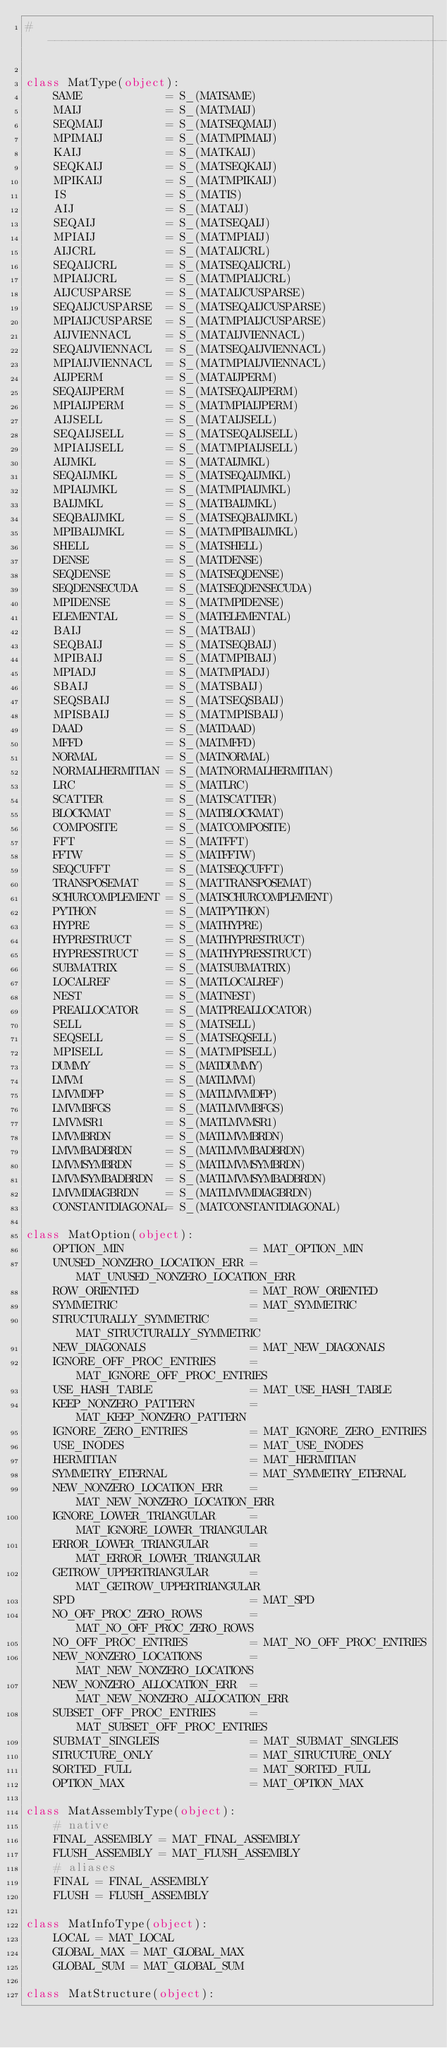Convert code to text. <code><loc_0><loc_0><loc_500><loc_500><_Cython_># --------------------------------------------------------------------

class MatType(object):
    SAME            = S_(MATSAME)
    MAIJ            = S_(MATMAIJ)
    SEQMAIJ         = S_(MATSEQMAIJ)
    MPIMAIJ         = S_(MATMPIMAIJ)
    KAIJ            = S_(MATKAIJ)
    SEQKAIJ         = S_(MATSEQKAIJ)
    MPIKAIJ         = S_(MATMPIKAIJ)
    IS              = S_(MATIS)
    AIJ             = S_(MATAIJ)
    SEQAIJ          = S_(MATSEQAIJ)
    MPIAIJ          = S_(MATMPIAIJ)
    AIJCRL          = S_(MATAIJCRL)
    SEQAIJCRL       = S_(MATSEQAIJCRL)
    MPIAIJCRL       = S_(MATMPIAIJCRL)
    AIJCUSPARSE     = S_(MATAIJCUSPARSE)
    SEQAIJCUSPARSE  = S_(MATSEQAIJCUSPARSE)
    MPIAIJCUSPARSE  = S_(MATMPIAIJCUSPARSE)
    AIJVIENNACL     = S_(MATAIJVIENNACL)
    SEQAIJVIENNACL  = S_(MATSEQAIJVIENNACL)
    MPIAIJVIENNACL  = S_(MATMPIAIJVIENNACL)
    AIJPERM         = S_(MATAIJPERM)
    SEQAIJPERM      = S_(MATSEQAIJPERM)
    MPIAIJPERM      = S_(MATMPIAIJPERM)
    AIJSELL         = S_(MATAIJSELL)
    SEQAIJSELL      = S_(MATSEQAIJSELL)
    MPIAIJSELL      = S_(MATMPIAIJSELL)
    AIJMKL          = S_(MATAIJMKL)
    SEQAIJMKL       = S_(MATSEQAIJMKL)
    MPIAIJMKL       = S_(MATMPIAIJMKL)
    BAIJMKL         = S_(MATBAIJMKL)
    SEQBAIJMKL      = S_(MATSEQBAIJMKL)
    MPIBAIJMKL      = S_(MATMPIBAIJMKL)
    SHELL           = S_(MATSHELL)
    DENSE           = S_(MATDENSE)
    SEQDENSE        = S_(MATSEQDENSE)
    SEQDENSECUDA    = S_(MATSEQDENSECUDA)
    MPIDENSE        = S_(MATMPIDENSE)
    ELEMENTAL       = S_(MATELEMENTAL)
    BAIJ            = S_(MATBAIJ)
    SEQBAIJ         = S_(MATSEQBAIJ)
    MPIBAIJ         = S_(MATMPIBAIJ)
    MPIADJ          = S_(MATMPIADJ)
    SBAIJ           = S_(MATSBAIJ)
    SEQSBAIJ        = S_(MATSEQSBAIJ)
    MPISBAIJ        = S_(MATMPISBAIJ)
    DAAD            = S_(MATDAAD)
    MFFD            = S_(MATMFFD)
    NORMAL          = S_(MATNORMAL)
    NORMALHERMITIAN = S_(MATNORMALHERMITIAN)
    LRC             = S_(MATLRC)
    SCATTER         = S_(MATSCATTER)
    BLOCKMAT        = S_(MATBLOCKMAT)
    COMPOSITE       = S_(MATCOMPOSITE)
    FFT             = S_(MATFFT)
    FFTW            = S_(MATFFTW)
    SEQCUFFT        = S_(MATSEQCUFFT)
    TRANSPOSEMAT    = S_(MATTRANSPOSEMAT)
    SCHURCOMPLEMENT = S_(MATSCHURCOMPLEMENT)
    PYTHON          = S_(MATPYTHON)
    HYPRE           = S_(MATHYPRE)
    HYPRESTRUCT     = S_(MATHYPRESTRUCT)
    HYPRESSTRUCT    = S_(MATHYPRESSTRUCT)
    SUBMATRIX       = S_(MATSUBMATRIX)
    LOCALREF        = S_(MATLOCALREF)
    NEST            = S_(MATNEST)
    PREALLOCATOR    = S_(MATPREALLOCATOR)
    SELL            = S_(MATSELL)
    SEQSELL         = S_(MATSEQSELL)
    MPISELL         = S_(MATMPISELL)
    DUMMY           = S_(MATDUMMY)
    LMVM            = S_(MATLMVM)
    LMVMDFP         = S_(MATLMVMDFP)
    LMVMBFGS        = S_(MATLMVMBFGS)
    LMVMSR1         = S_(MATLMVMSR1)
    LMVMBRDN        = S_(MATLMVMBRDN)
    LMVMBADBRDN     = S_(MATLMVMBADBRDN)
    LMVMSYMBRDN     = S_(MATLMVMSYMBRDN)
    LMVMSYMBADBRDN  = S_(MATLMVMSYMBADBRDN)
    LMVMDIAGBRDN    = S_(MATLMVMDIAGBRDN)
    CONSTANTDIAGONAL= S_(MATCONSTANTDIAGONAL)

class MatOption(object):
    OPTION_MIN                  = MAT_OPTION_MIN
    UNUSED_NONZERO_LOCATION_ERR = MAT_UNUSED_NONZERO_LOCATION_ERR
    ROW_ORIENTED                = MAT_ROW_ORIENTED
    SYMMETRIC                   = MAT_SYMMETRIC
    STRUCTURALLY_SYMMETRIC      = MAT_STRUCTURALLY_SYMMETRIC
    NEW_DIAGONALS               = MAT_NEW_DIAGONALS
    IGNORE_OFF_PROC_ENTRIES     = MAT_IGNORE_OFF_PROC_ENTRIES
    USE_HASH_TABLE              = MAT_USE_HASH_TABLE
    KEEP_NONZERO_PATTERN        = MAT_KEEP_NONZERO_PATTERN
    IGNORE_ZERO_ENTRIES         = MAT_IGNORE_ZERO_ENTRIES
    USE_INODES                  = MAT_USE_INODES
    HERMITIAN                   = MAT_HERMITIAN
    SYMMETRY_ETERNAL            = MAT_SYMMETRY_ETERNAL
    NEW_NONZERO_LOCATION_ERR    = MAT_NEW_NONZERO_LOCATION_ERR
    IGNORE_LOWER_TRIANGULAR     = MAT_IGNORE_LOWER_TRIANGULAR
    ERROR_LOWER_TRIANGULAR      = MAT_ERROR_LOWER_TRIANGULAR
    GETROW_UPPERTRIANGULAR      = MAT_GETROW_UPPERTRIANGULAR
    SPD                         = MAT_SPD
    NO_OFF_PROC_ZERO_ROWS       = MAT_NO_OFF_PROC_ZERO_ROWS
    NO_OFF_PROC_ENTRIES         = MAT_NO_OFF_PROC_ENTRIES
    NEW_NONZERO_LOCATIONS       = MAT_NEW_NONZERO_LOCATIONS
    NEW_NONZERO_ALLOCATION_ERR  = MAT_NEW_NONZERO_ALLOCATION_ERR
    SUBSET_OFF_PROC_ENTRIES     = MAT_SUBSET_OFF_PROC_ENTRIES
    SUBMAT_SINGLEIS             = MAT_SUBMAT_SINGLEIS
    STRUCTURE_ONLY              = MAT_STRUCTURE_ONLY
    SORTED_FULL                 = MAT_SORTED_FULL
    OPTION_MAX                  = MAT_OPTION_MAX

class MatAssemblyType(object):
    # native
    FINAL_ASSEMBLY = MAT_FINAL_ASSEMBLY
    FLUSH_ASSEMBLY = MAT_FLUSH_ASSEMBLY
    # aliases
    FINAL = FINAL_ASSEMBLY
    FLUSH = FLUSH_ASSEMBLY

class MatInfoType(object):
    LOCAL = MAT_LOCAL
    GLOBAL_MAX = MAT_GLOBAL_MAX
    GLOBAL_SUM = MAT_GLOBAL_SUM

class MatStructure(object):</code> 